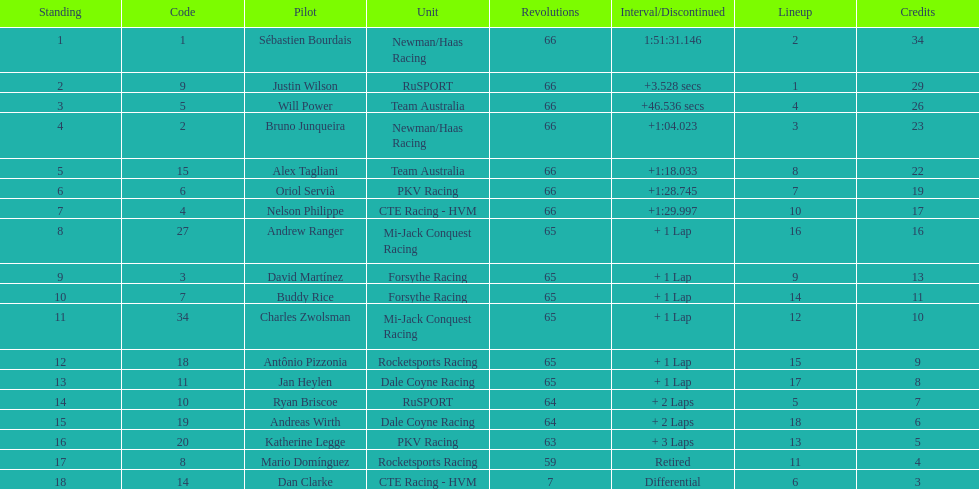Rice finished 10th. who finished next? Charles Zwolsman. 